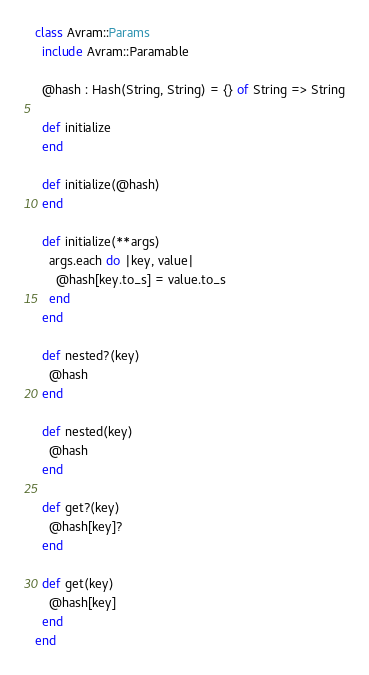Convert code to text. <code><loc_0><loc_0><loc_500><loc_500><_Crystal_>class Avram::Params
  include Avram::Paramable

  @hash : Hash(String, String) = {} of String => String

  def initialize
  end

  def initialize(@hash)
  end

  def initialize(**args)
    args.each do |key, value|
      @hash[key.to_s] = value.to_s
    end
  end

  def nested?(key)
    @hash
  end

  def nested(key)
    @hash
  end

  def get?(key)
    @hash[key]?
  end

  def get(key)
    @hash[key]
  end
end
</code> 